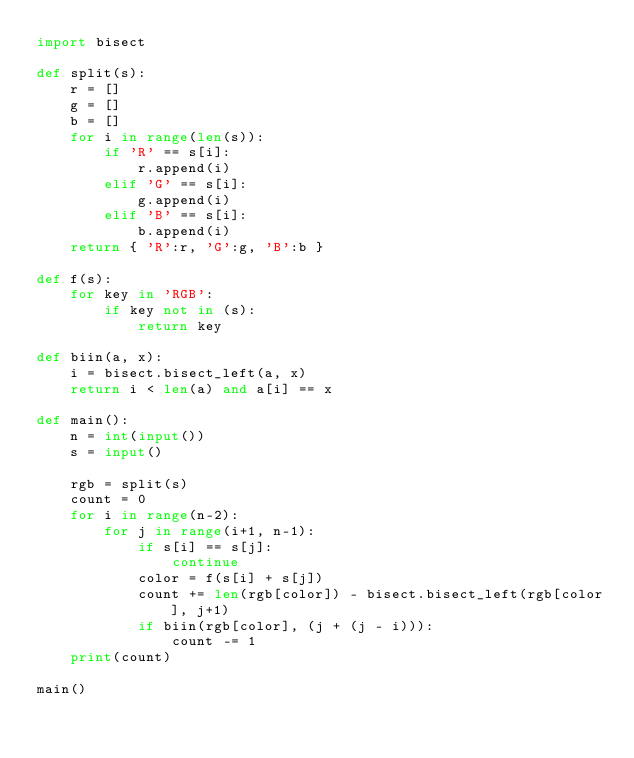<code> <loc_0><loc_0><loc_500><loc_500><_Python_>import bisect

def split(s):
    r = []
    g = []
    b = []
    for i in range(len(s)):
        if 'R' == s[i]:
            r.append(i)
        elif 'G' == s[i]:
            g.append(i)
        elif 'B' == s[i]:
            b.append(i)
    return { 'R':r, 'G':g, 'B':b }

def f(s):
    for key in 'RGB':
        if key not in (s):
            return key

def biin(a, x):
    i = bisect.bisect_left(a, x)
    return i < len(a) and a[i] == x

def main():
    n = int(input())
    s = input()

    rgb = split(s)
    count = 0
    for i in range(n-2):
        for j in range(i+1, n-1):
            if s[i] == s[j]:
                continue
            color = f(s[i] + s[j])
            count += len(rgb[color]) - bisect.bisect_left(rgb[color], j+1)
            if biin(rgb[color], (j + (j - i))):
                count -= 1
    print(count)

main()
</code> 